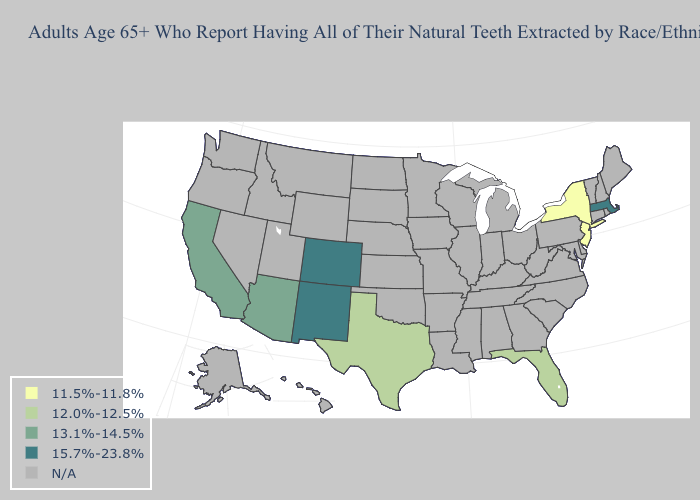What is the value of Massachusetts?
Short answer required. 15.7%-23.8%. Does New Mexico have the highest value in the USA?
Be succinct. Yes. What is the value of New Mexico?
Be succinct. 15.7%-23.8%. Name the states that have a value in the range 12.0%-12.5%?
Write a very short answer. Florida, Texas. What is the value of Michigan?
Keep it brief. N/A. What is the highest value in states that border Utah?
Give a very brief answer. 15.7%-23.8%. Does California have the highest value in the USA?
Write a very short answer. No. Name the states that have a value in the range 13.1%-14.5%?
Be succinct. Arizona, California. What is the value of Delaware?
Concise answer only. N/A. Name the states that have a value in the range 11.5%-11.8%?
Concise answer only. New Jersey, New York. What is the highest value in the USA?
Concise answer only. 15.7%-23.8%. What is the lowest value in the South?
Concise answer only. 12.0%-12.5%. 